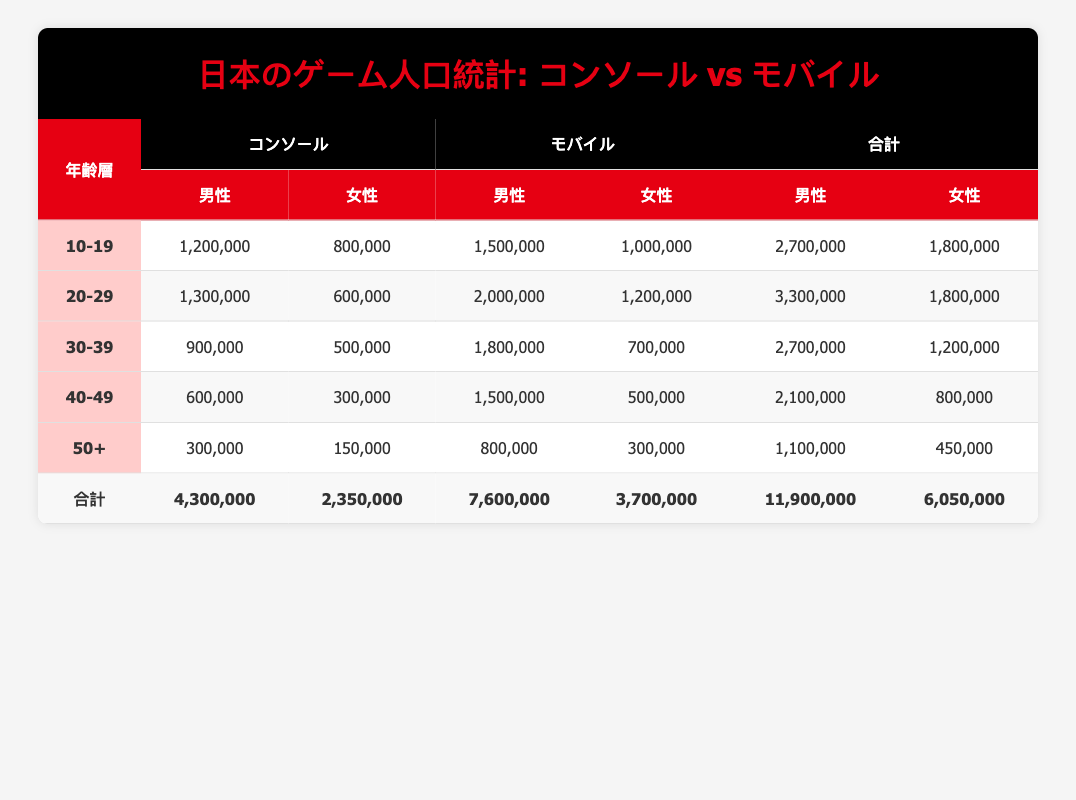What is the total player count for male players aged 20-29 on both platforms? For male players aged 20-29, the console count is 1,300,000, and the mobile count is 2,000,000. Adding these gives: 1,300,000 + 2,000,000 = 3,300,000.
Answer: 3,300,000 How many female players aged 30-39 play mobile games? According to the table, the player count for females aged 30-39 on mobile is listed as 700,000.
Answer: 700,000 Is there a higher number of male players on mobile or console for the 40-49 age group? For the 40-49 age group, male players count is 600,000 on console and 1,500,000 on mobile. Since 1,500,000 (mobile) is greater than 600,000 (console), the answer is yes.
Answer: Yes What is the difference in player count between female players aged 10-19 on mobile and console? Female players aged 10-19 on console total 800,000, and on mobile, they total 1,000,000. To find the difference: 1,000,000 - 800,000 = 200,000.
Answer: 200,000 Calculate the total number of players aged 50+ across both platforms. For the 50+ age group, the total player count is 300,000 (males on console) + 150,000 (females on console) + 800,000 (males on mobile) + 300,000 (females on mobile) = 1,500,000.
Answer: 1,500,000 Are there more players aged 30-39 in total on console or mobile? For the 30-39 age group: Console has 900,000 (males) + 500,000 (females) = 1,400,000; Mobile has 1,800,000 (males) + 700,000 (females) = 2,500,000. Since 2,500,000 (mobile) is greater than 1,400,000 (console), the answer is mobile has more players.
Answer: Mobile What is the percentage of male players in the 10-19 age group for console games? The total count for the 10-19 age group is 1,200,000 (male) + 800,000 (female) = 2,000,000. The percentage of male players is then (1,200,000 / 2,000,000) * 100 = 60%.
Answer: 60% How many total players aged 40-49 play console games? For players aged 40-49 on console, male count is 600,000 and female count is 300,000. Adding these gives: 600,000 + 300,000 = 900,000 total players.
Answer: 900,000 What is the total number of male players across all age groups for mobile? The sum of male players on mobile across all age groups is: 1,500,000 (10-19) + 2,000,000 (20-29) + 1,800,000 (30-39) + 1,500,000 (40-49) + 800,000 (50+) = 7,600,000.
Answer: 7,600,000 